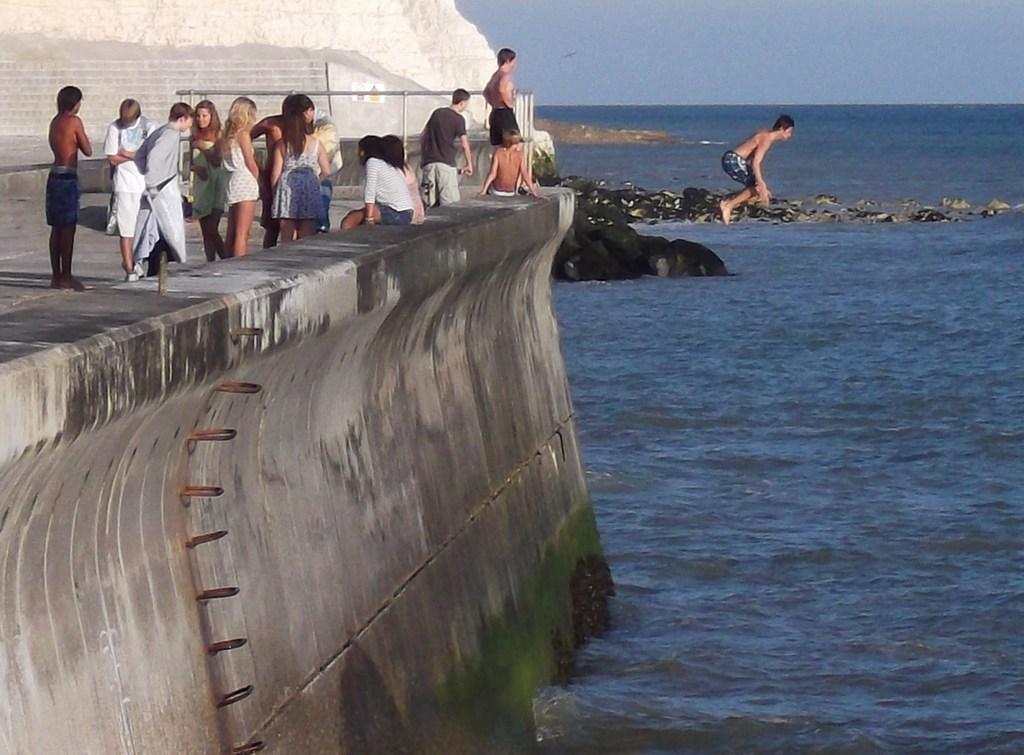Could you give a brief overview of what you see in this image? In this image we can see a group of people are standing, there a man is jumping, there is the water, there are rocks, there is sky at the top. 